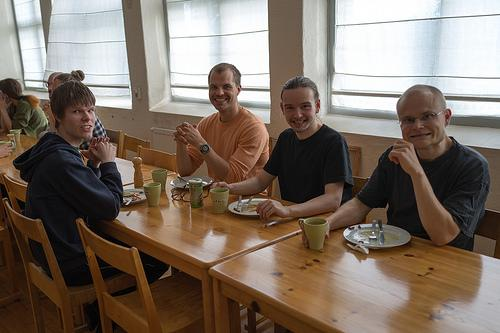How many people are sitting at the table in the image? Three people are sitting at the table. Describe the position and action of the person holding the cup. The man holding the cup is positioned at the right side of the table, slightly raised up. He has his fingers wrapped around the cup and is presumably about to take a sip. Mention the materials of the objects on the table. Wood, silver metal, and ceramic. Provide a brief narrative of the scene displayed in the image. A group of people are sitting at a wooden table with various objects on it such as plates, cutlery, and a cup. The people seem to be enjoying each other's company, and one of the men is wearing glasses. What is a prominent object on a wooden table other than plates? A wooden salt shaker is a prominent object on the wooden table. Identify an emotion displayed by the subjects in the image. At least one man is smiling, conveying happiness. Identify the colors of the shirts worn by the subjects in the image. Black, light orange, and blue. List all the objects that can be found in the image. Wooden chair, white plates, wooden table, silver knife and fork, wooden salt shaker, man in blue jacket, man holding a cup, man in orange shirt, shadows, napkin, sauce, salt shaker, man wearing glasses, people sitting at table. Examine the condition of the used plate on the table and provide a brief description. There is leftover sauce on the plate, indicating that a meal was consumed. Describe the appearance of the person wearing glasses in the image. The man wearing glasses has an oval-shaped face and a relatively prominent nose. His hair appears to be short or tied back, and he is wearing a black shirt. Describe the person wearing glasses in this image. A man wearing glasses, a dark shirt, and has his hand on a cup. Does the man holding the cup have long hair and a beard? No, it's not mentioned in the image. Can you tell the color of the cup in the image? The cup is brown. Mention an object that is not touching the table in the image. A man's elbow Describe the shadow in the image. Shadow is cast by a man on the light brown wooden table. Explain the location of the salt shaker in the image. The light brown wooden salt shaker is on the wooden table. What is the color of the plate on the table? The plate is white. State an observation about the shirts of people in the image. Some shirts are orange, some are black, and some are blue. What are the people doing in the image? The people are sitting at the wooden table. Identify the type of table in the image. Rectangular light brown wooden table Select the correct statement based on the image:  b) There is only one plate on the table Describe the arrangement of knife and fork on the plate. A knife and fork are sitting on the white plate. List the objects found on the table in the image. circular white plates, knife and fork, wooden salt shaker, cup, paper napkin Elaborate on the interaction between the man and the cup. A man has his hand on a cup, with his fingers wrapped around it and his thumb on it. Examine any leftover food on the plate. Leftover sauce on the plate What does a man wear on his wrist in this image? A watch Explain the appearance of a man in the image who is wearing a blue jacket. A man is wearing a blue jacket, jeans, and sitting at the wooden table. Identify the color and material of the chair in the image. The chair is light brown and wooden. 